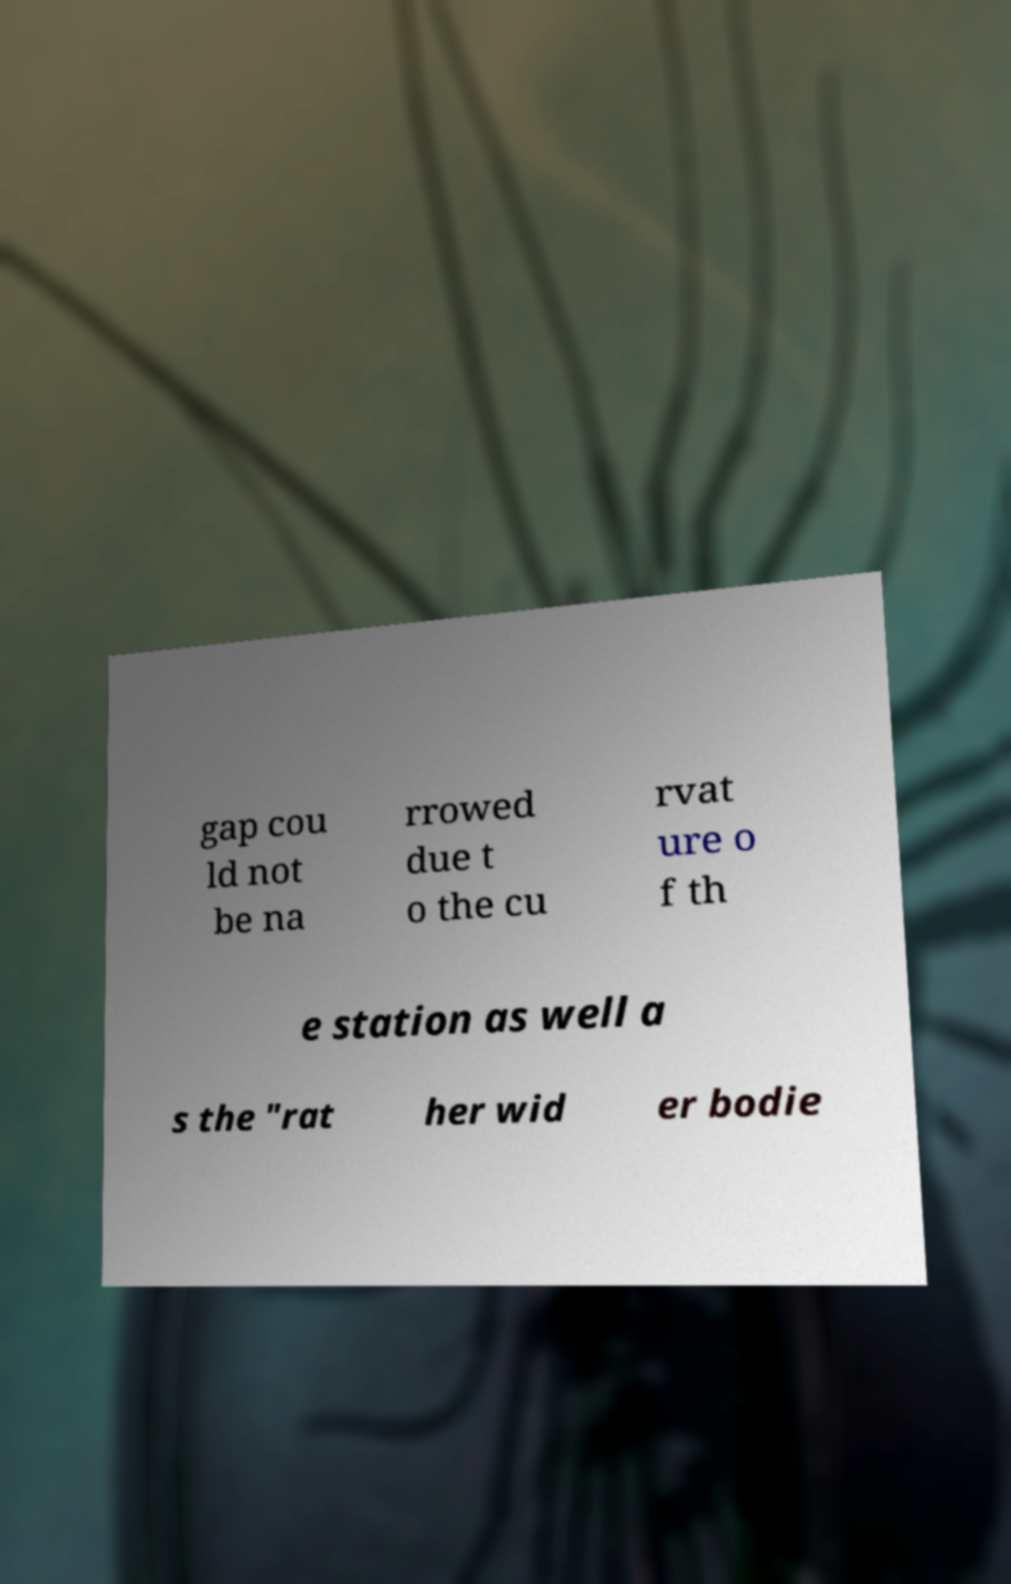Could you extract and type out the text from this image? gap cou ld not be na rrowed due t o the cu rvat ure o f th e station as well a s the "rat her wid er bodie 